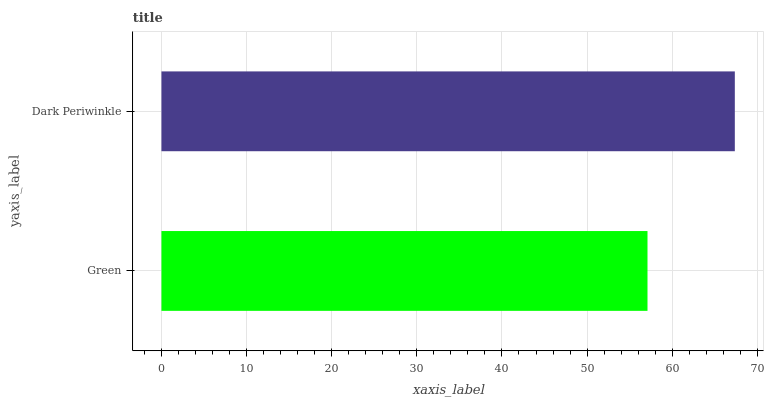Is Green the minimum?
Answer yes or no. Yes. Is Dark Periwinkle the maximum?
Answer yes or no. Yes. Is Dark Periwinkle the minimum?
Answer yes or no. No. Is Dark Periwinkle greater than Green?
Answer yes or no. Yes. Is Green less than Dark Periwinkle?
Answer yes or no. Yes. Is Green greater than Dark Periwinkle?
Answer yes or no. No. Is Dark Periwinkle less than Green?
Answer yes or no. No. Is Dark Periwinkle the high median?
Answer yes or no. Yes. Is Green the low median?
Answer yes or no. Yes. Is Green the high median?
Answer yes or no. No. Is Dark Periwinkle the low median?
Answer yes or no. No. 